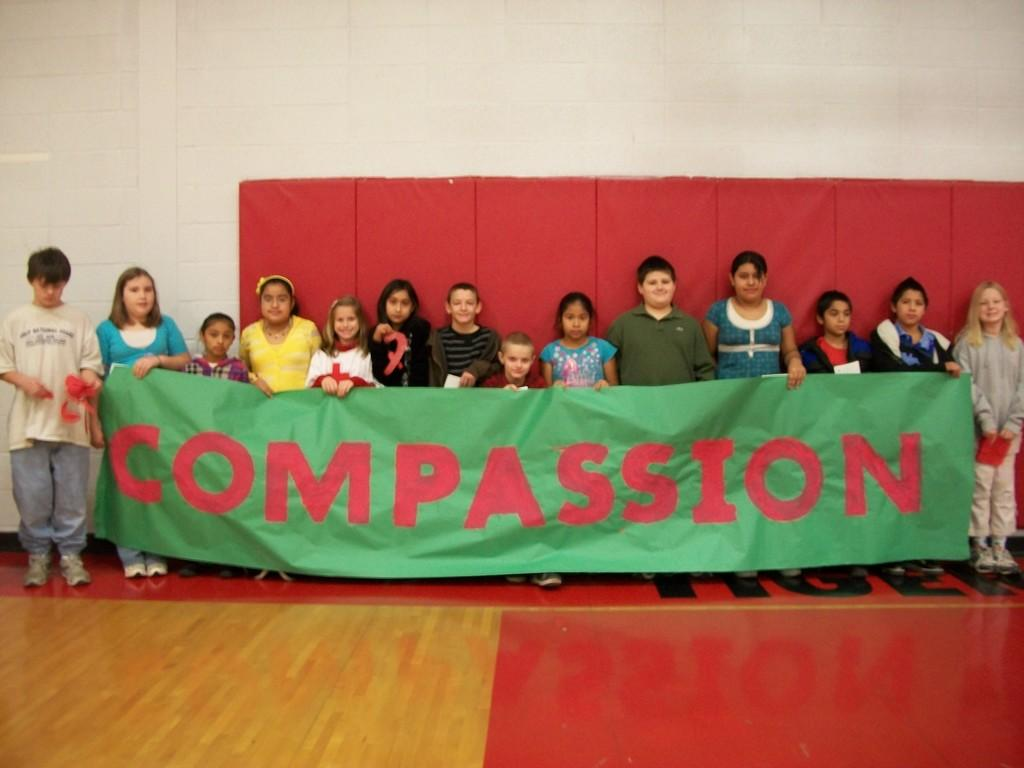Who is present in the image? There are children in the image. What are the children holding in the image? The children are holding a green color flex. Can you describe the gender of the children in the image? There are both boys and girls in the image. What can be seen in the background of the image? There is a wall in the background of the image. Can you hear the voice of the giraffe in the image? There is no giraffe present in the image, so it is not possible to hear its voice. How many wrens can be seen in the image? There are no wrens present in the image. 